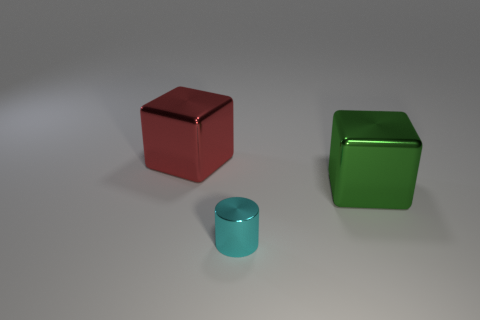What number of other tiny cyan objects are the same shape as the small metallic thing?
Your response must be concise. 0. Is the shape of the large red shiny thing the same as the large green shiny thing?
Make the answer very short. Yes. Do the thing that is in front of the green block and the shiny block in front of the big red metallic cube have the same size?
Your response must be concise. No. What shape is the big metallic thing that is behind the big green cube?
Provide a succinct answer. Cube. There is a red shiny object; is it the same size as the object on the right side of the cylinder?
Offer a very short reply. Yes. How many green metallic things are in front of the big object in front of the object behind the green shiny thing?
Offer a very short reply. 0. What number of large metallic objects are behind the large green thing?
Your answer should be compact. 1. What is the color of the thing left of the tiny cyan metallic cylinder to the right of the red cube?
Give a very brief answer. Red. What number of other things are there of the same material as the big red cube
Keep it short and to the point. 2. Are there the same number of red things that are behind the red metal object and tiny yellow shiny cubes?
Offer a very short reply. Yes. 